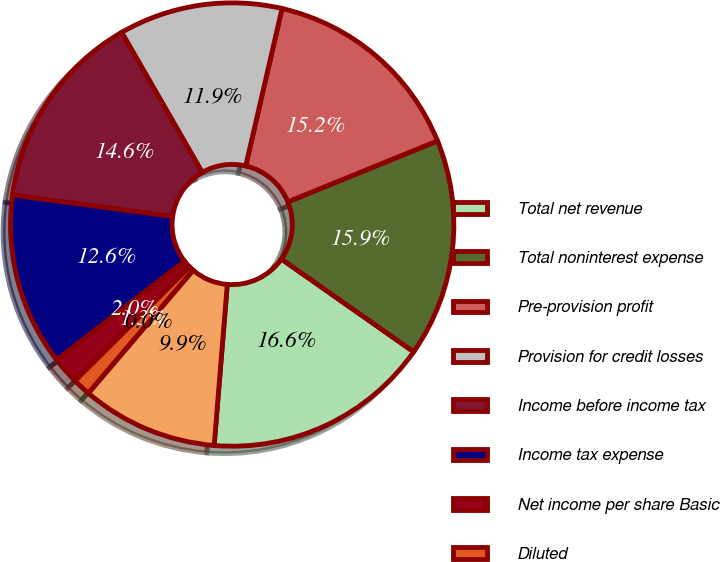Convert chart to OTSL. <chart><loc_0><loc_0><loc_500><loc_500><pie_chart><fcel>Total net revenue<fcel>Total noninterest expense<fcel>Pre-provision profit<fcel>Provision for credit losses<fcel>Income before income tax<fcel>Income tax expense<fcel>Net income per share Basic<fcel>Diluted<fcel>Cash dividends declared per<fcel>Book value per share<nl><fcel>16.56%<fcel>15.89%<fcel>15.23%<fcel>11.92%<fcel>14.57%<fcel>12.58%<fcel>1.99%<fcel>1.32%<fcel>0.0%<fcel>9.93%<nl></chart> 